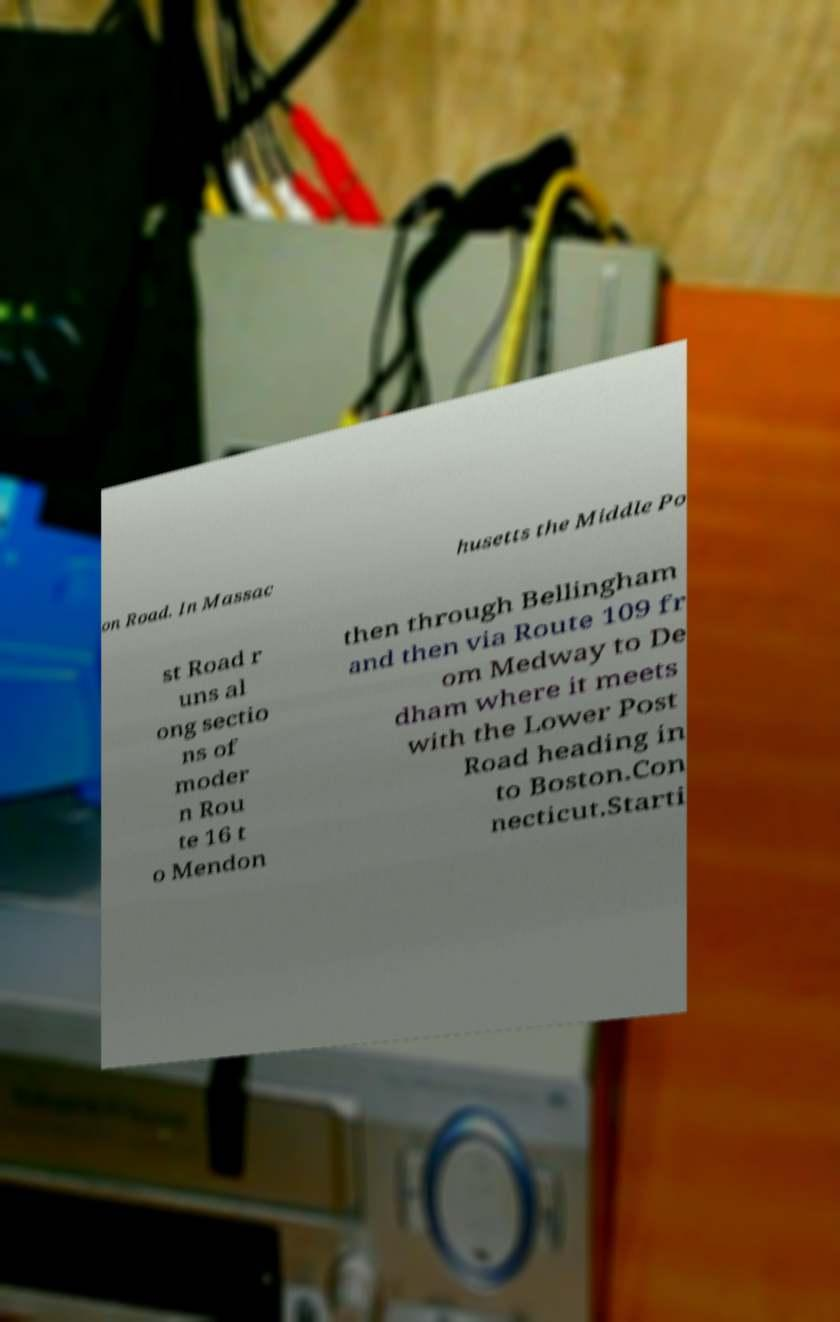Please identify and transcribe the text found in this image. on Road. In Massac husetts the Middle Po st Road r uns al ong sectio ns of moder n Rou te 16 t o Mendon then through Bellingham and then via Route 109 fr om Medway to De dham where it meets with the Lower Post Road heading in to Boston.Con necticut.Starti 